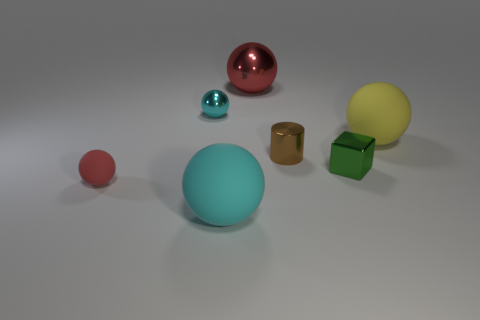Is the number of brown metallic cylinders to the left of the big cyan ball greater than the number of small brown shiny things that are in front of the green metallic thing?
Give a very brief answer. No. Is the color of the small object that is behind the yellow rubber thing the same as the big ball right of the tiny cylinder?
Ensure brevity in your answer.  No. There is a shiny thing on the left side of the big sphere behind the cyan ball that is behind the shiny cube; what size is it?
Provide a succinct answer. Small. What color is the large metal thing that is the same shape as the red rubber object?
Ensure brevity in your answer.  Red. Is the number of tiny red objects to the right of the cylinder greater than the number of green spheres?
Your answer should be compact. No. Is the shape of the yellow object the same as the red object that is behind the large yellow ball?
Your response must be concise. Yes. Is there any other thing that has the same size as the cyan metallic thing?
Ensure brevity in your answer.  Yes. The other red object that is the same shape as the big metallic object is what size?
Keep it short and to the point. Small. Is the number of brown metal objects greater than the number of small gray rubber cylinders?
Offer a terse response. Yes. Is the brown metallic object the same shape as the big yellow matte thing?
Offer a very short reply. No. 